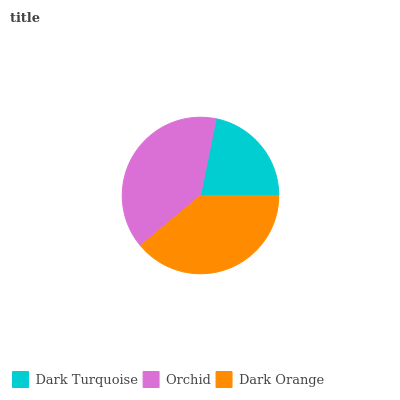Is Dark Turquoise the minimum?
Answer yes or no. Yes. Is Orchid the maximum?
Answer yes or no. Yes. Is Dark Orange the minimum?
Answer yes or no. No. Is Dark Orange the maximum?
Answer yes or no. No. Is Orchid greater than Dark Orange?
Answer yes or no. Yes. Is Dark Orange less than Orchid?
Answer yes or no. Yes. Is Dark Orange greater than Orchid?
Answer yes or no. No. Is Orchid less than Dark Orange?
Answer yes or no. No. Is Dark Orange the high median?
Answer yes or no. Yes. Is Dark Orange the low median?
Answer yes or no. Yes. Is Dark Turquoise the high median?
Answer yes or no. No. Is Orchid the low median?
Answer yes or no. No. 